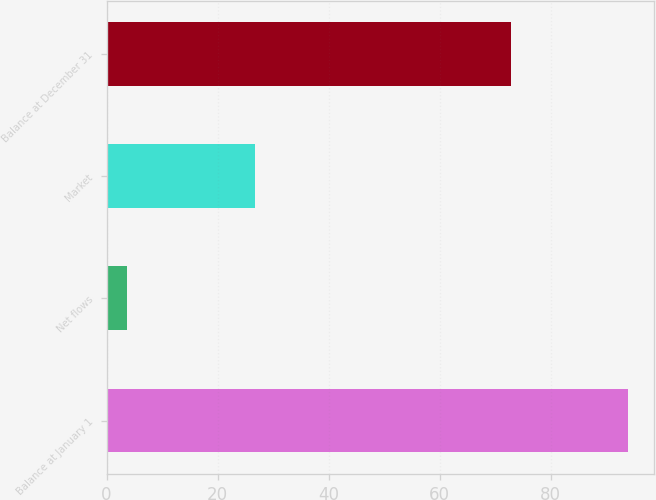<chart> <loc_0><loc_0><loc_500><loc_500><bar_chart><fcel>Balance at January 1<fcel>Net flows<fcel>Market<fcel>Balance at December 31<nl><fcel>93.9<fcel>3.7<fcel>26.8<fcel>72.8<nl></chart> 